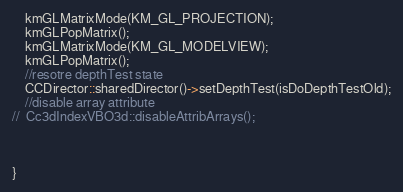Convert code to text. <code><loc_0><loc_0><loc_500><loc_500><_C++_>    kmGLMatrixMode(KM_GL_PROJECTION);
    kmGLPopMatrix();
    kmGLMatrixMode(KM_GL_MODELVIEW);
    kmGLPopMatrix();
    //resotre depthTest state
    CCDirector::sharedDirector()->setDepthTest(isDoDepthTestOld);
	//disable array attribute
//	Cc3dIndexVBO3d::disableAttribArrays();
    
    
    
}</code> 